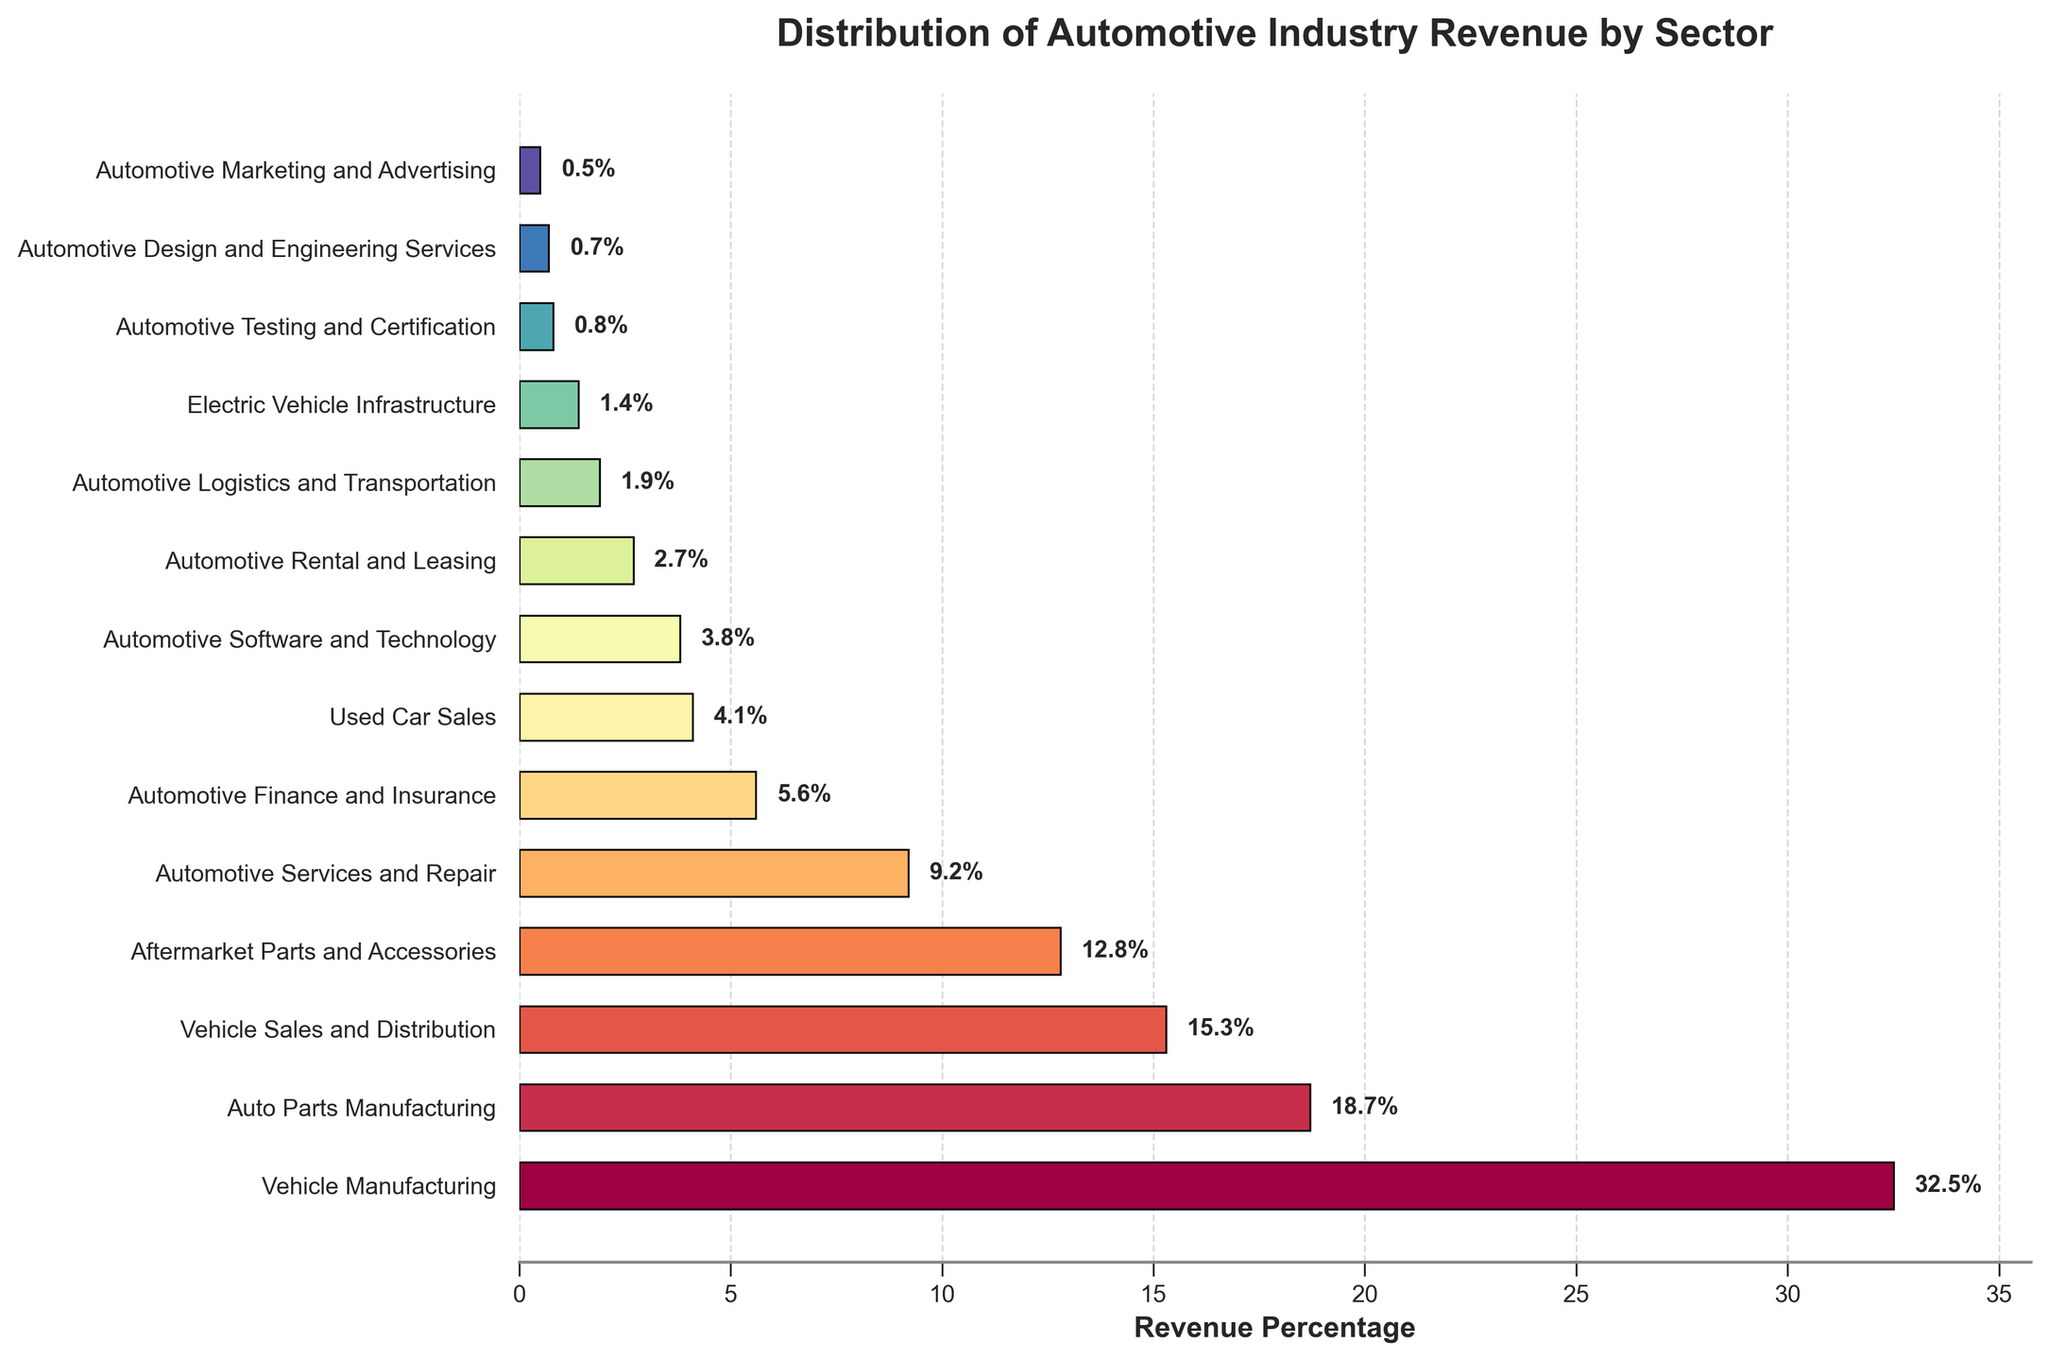What's the total percentage of revenue contributed by the Vehicle Manufacturing and Auto Parts Manufacturing sectors? Add the revenue percentages of both sectors: 32.5% (Vehicle Manufacturing) + 18.7% (Auto Parts Manufacturing) = 51.2%
Answer: 51.2% Which sector contributes more to the revenue: Automotive Services and Repair or Automotive Finance and Insurance? Compare the revenue percentages of the two sectors: 9.2% (Automotive Services and Repair) vs. 5.6% (Automotive Finance and Insurance). 9.2% is greater than 5.6%
Answer: Automotive Services and Repair What is the difference in revenue percentage between Vehicle Sales and Distribution and Used Car Sales? Subtract the revenue percentage of Used Car Sales from Vehicle Sales and Distribution: 15.3% - 4.1% = 11.2%
Answer: 11.2% What's the combined revenue percentage of the three smallest sectors? Add the revenue percentages of the three smallest sectors: 0.5% (Automotive Marketing and Advertising) + 0.7% (Automotive Design and Engineering Services) + 0.8% (Automotive Testing and Certification) = 2.0%
Answer: 2.0% Which sector has the longest bar in the chart? The sector with the longest bar corresponds to the highest revenue percentage, which is Vehicle Manufacturing at 32.5%
Answer: Vehicle Manufacturing Is the revenue percentage of Aftermarket Parts and Accessories higher than Automotive Finance and Insurance? Compare the revenue percentages: 12.8% (Aftermarket Parts and Accessories) vs. 5.6% (Automotive Finance and Insurance). 12.8% is greater than 5.6%
Answer: Yes What is the median revenue percentage of all sectors? List the revenue percentages in ascending order: 0.5%, 0.7%, 0.8%, 1.4%, 1.9%, 2.7%, 3.8%, 4.1%, 5.6%, 9.2%, 12.8%, 15.3%, 18.7%, 32.5%. The median is the middle value, so the 7th and 8th values are 3.8% and 4.1%, respectively. Median = (3.8% + 4.1%) / 2 = 3.95%
Answer: 3.95% How many sectors have a revenue percentage less than 10%? Count the sectors with revenue percentages below 10%: Auto Parts Manufacturing (18.7%), Aftermarket Parts and Accessories (12.8%), Vehicle Sales and Distribution (15.3%) are excluded; remaining are below 10%: 10 sectors
Answer: 10 sectors For the Vehicle Manufacturing sector, where is the revenue percentage label located on the bar? The label for Vehicle Manufacturing (32.5%) is located to the right of the bar
Answer: Right of the bar 